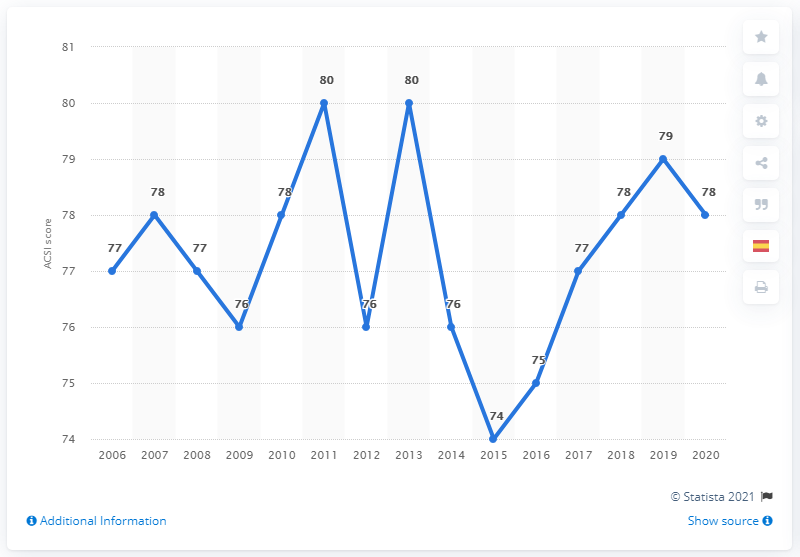What does this graph show about the trend in Starbucks' ACSI scores over the years? The graph illustrates the fluctuations in Starbucks' American Customer Satisfaction Index (ACSI) scores from 2006 to 2020. Overall, the trend shows variability, with notable peaks and dips. For instance, the score peaked at 80 in 2011 and 2013, with a sharp decline to 74 in 2015 before recovering. The score appears to have stabilized at 78 in recent years, suggesting improved and consistent customer satisfaction levels. 